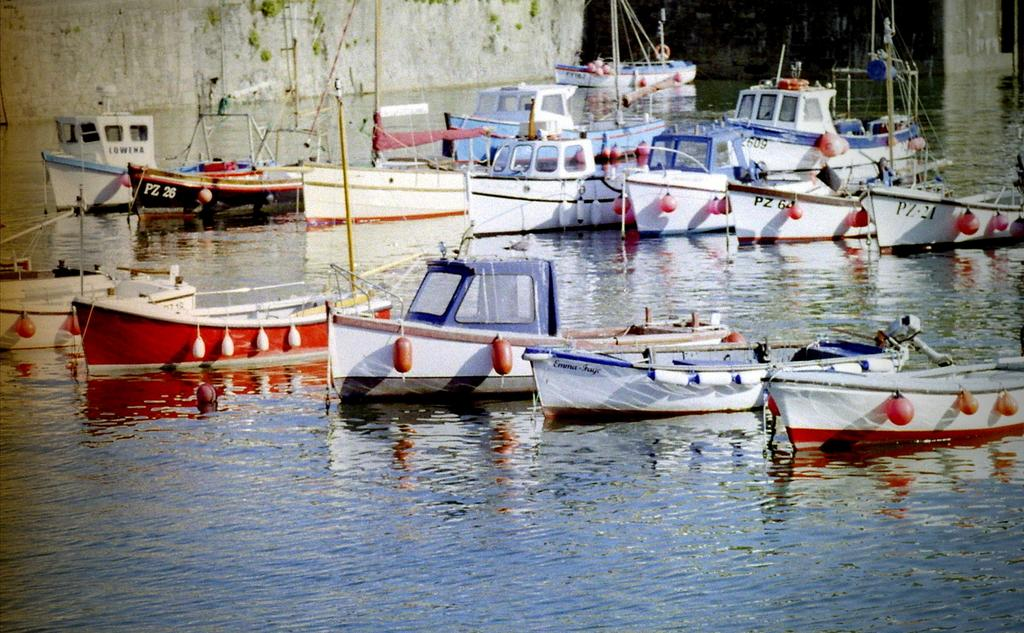What is the primary element in the image? There is water in the image. What can be seen floating on the water? There are boats in the image. What colors are the boats? The boats are white, blue, and red in color. What is visible in the background of the image? There is a wall in the background of the image. How many cattle can be seen grazing near the wall in the image? There are no cattle present in the image; it features water, boats, and a wall. Are there any women visible in the image? There is no mention of women in the provided facts, and therefore we cannot determine if any are present in the image. 